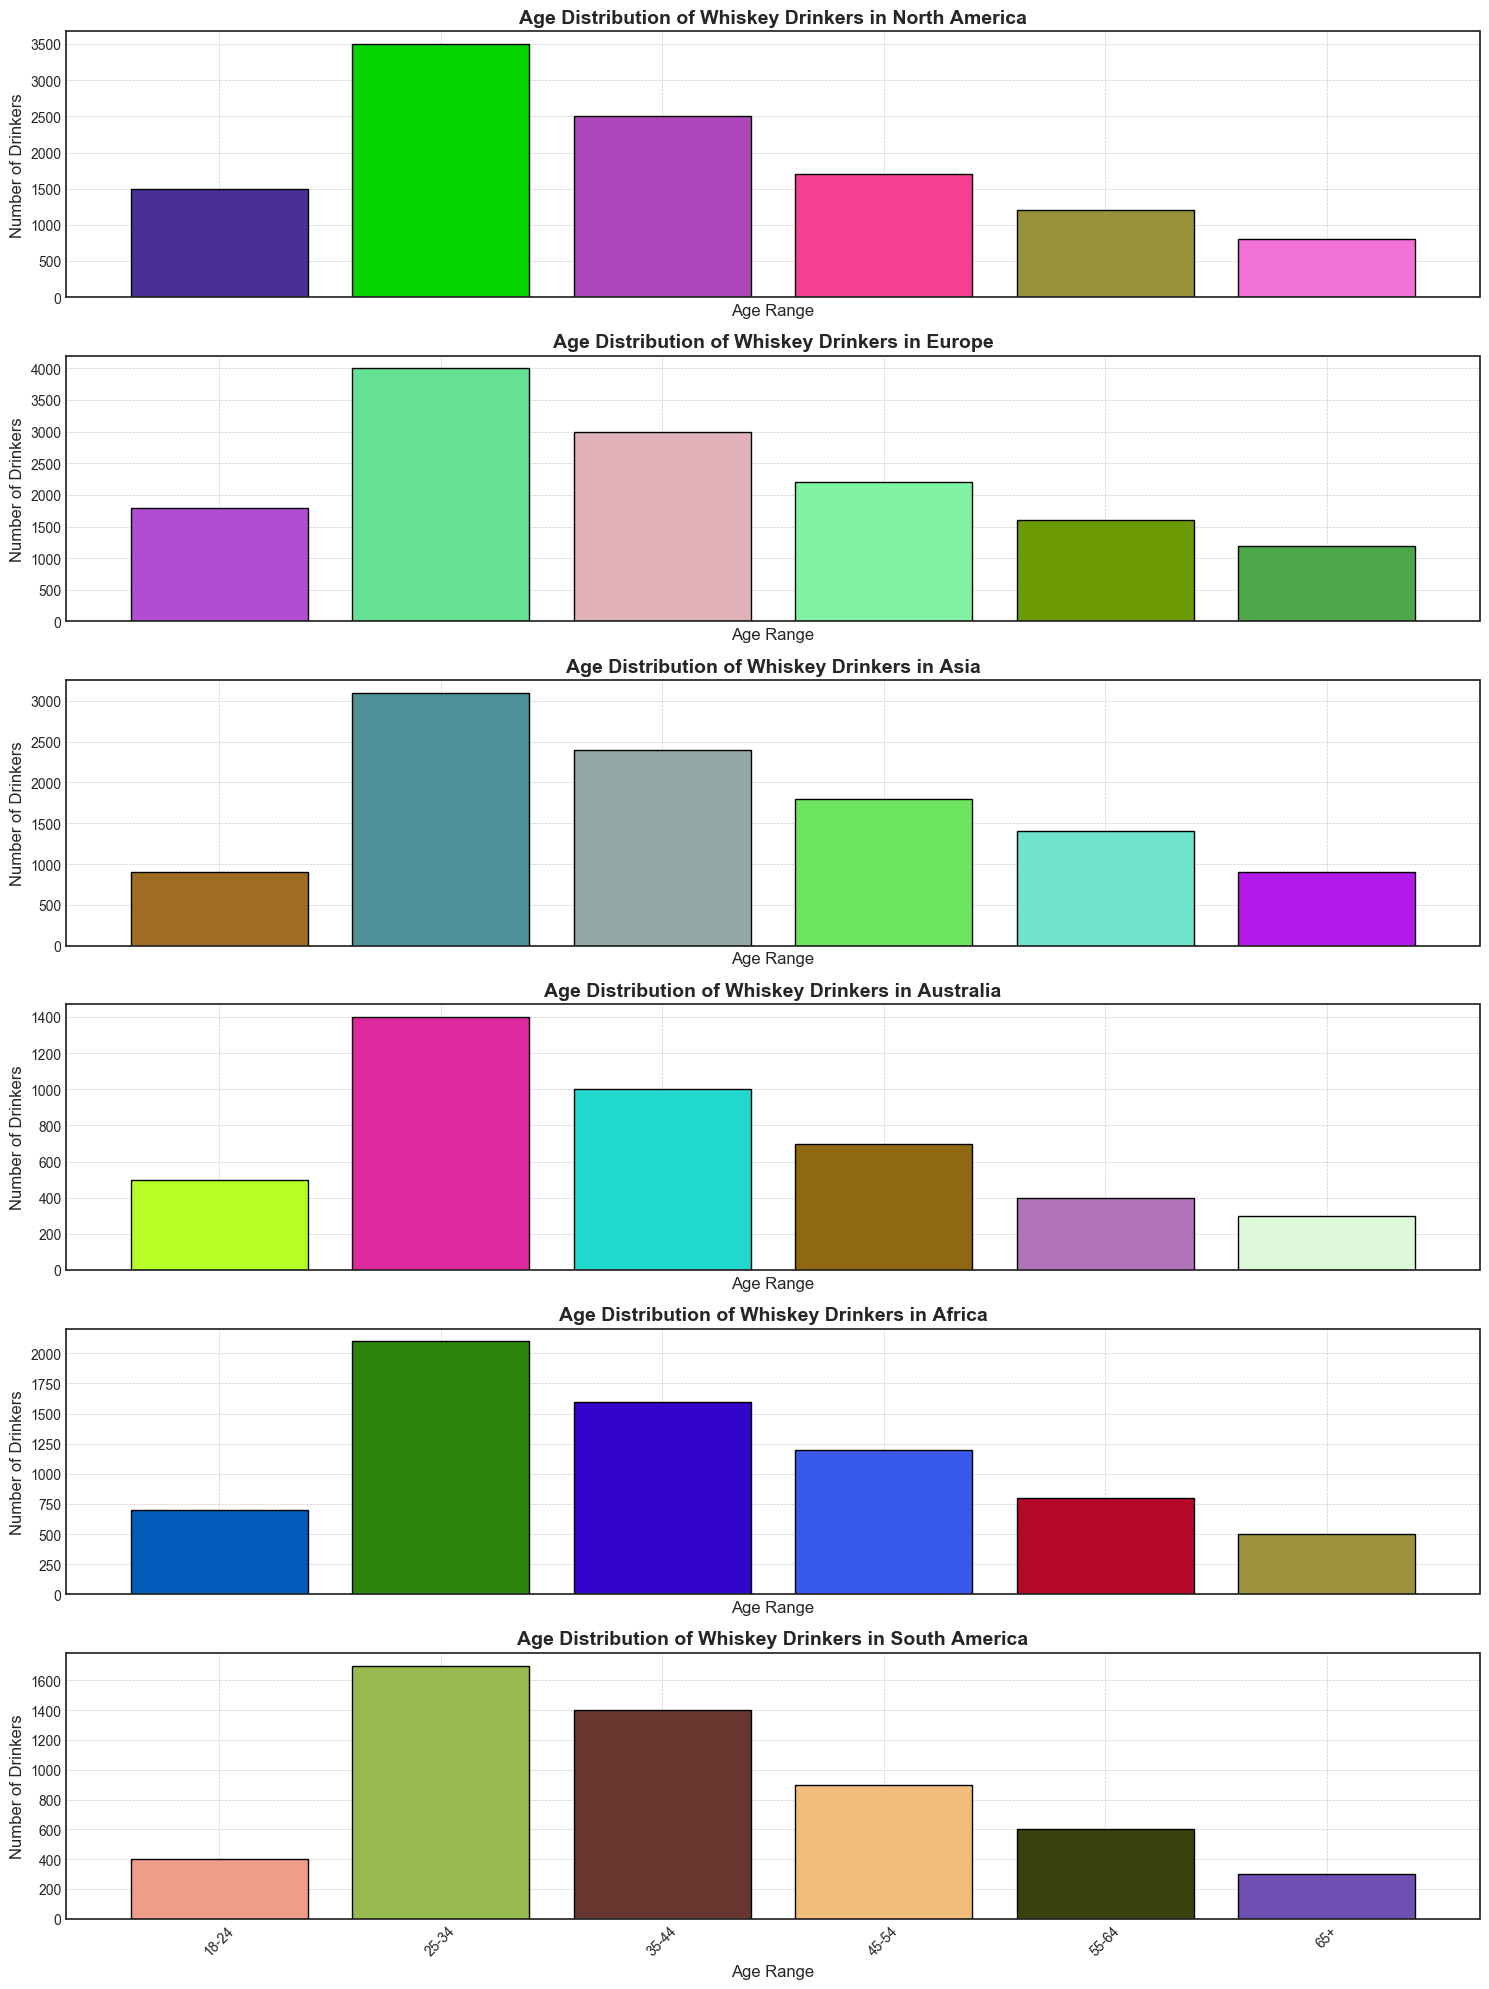Which region has the highest number of whiskey drinkers in the 25-34 age range? Looking at the height of the bars in each subplot, the tallest bar in the 25-34 age range is in Europe.
Answer: Europe In Asia, is the number of whiskey drinkers aged 25-34 greater than all other age ranges combined? The number of drinkers aged 25-34 in Asia is 3100. Adding up the numbers from the other age ranges (900 + 2400 + 1800 + 1400 + 900) gives 7400. Hence, no, 3100 is not greater than 7400.
Answer: No Which age range has the smallest number of whiskey drinkers in North America? The shortest bar in the North America subplot corresponds to the 65+ age range.
Answer: 65+ What is the total number of whiskey drinkers in Europe? Summing up all the bars in the Europe subplot (1800 + 4000 + 3000 + 2200 + 1600 + 1200) gives 13800.
Answer: 13800 Compare the number of whiskey drinkers aged 45-54 in Africa to those in South America. The number of drinkers aged 45-54 in Africa is 1200, whereas in South America, it is 900. Therefore, Africa has more drinkers in this age range.
Answer: Africa What is the difference in the number of whiskey drinkers aged 35-44 between Asia and Australia? The number of drinkers aged 35-44 in Asia is 2400, while in Australia, it is 1000. The difference is 2400 - 1000 = 1400.
Answer: 1400 How many more whiskey drinkers aged 55-64 are there in Europe compared to Africa? In Europe, there are 1600 drinkers aged 55-64, while in Africa, there are 800. The difference is 1600 - 800 = 800.
Answer: 800 Is the number of whiskey drinkers aged 18-24 in North America greater than those in Australia and South America combined? In North America, the number of drinkers aged 18-24 is 1500. In Australia and South America combined (500 + 400), it totals 900. Therefore, 1500 is greater than 900.
Answer: Yes 